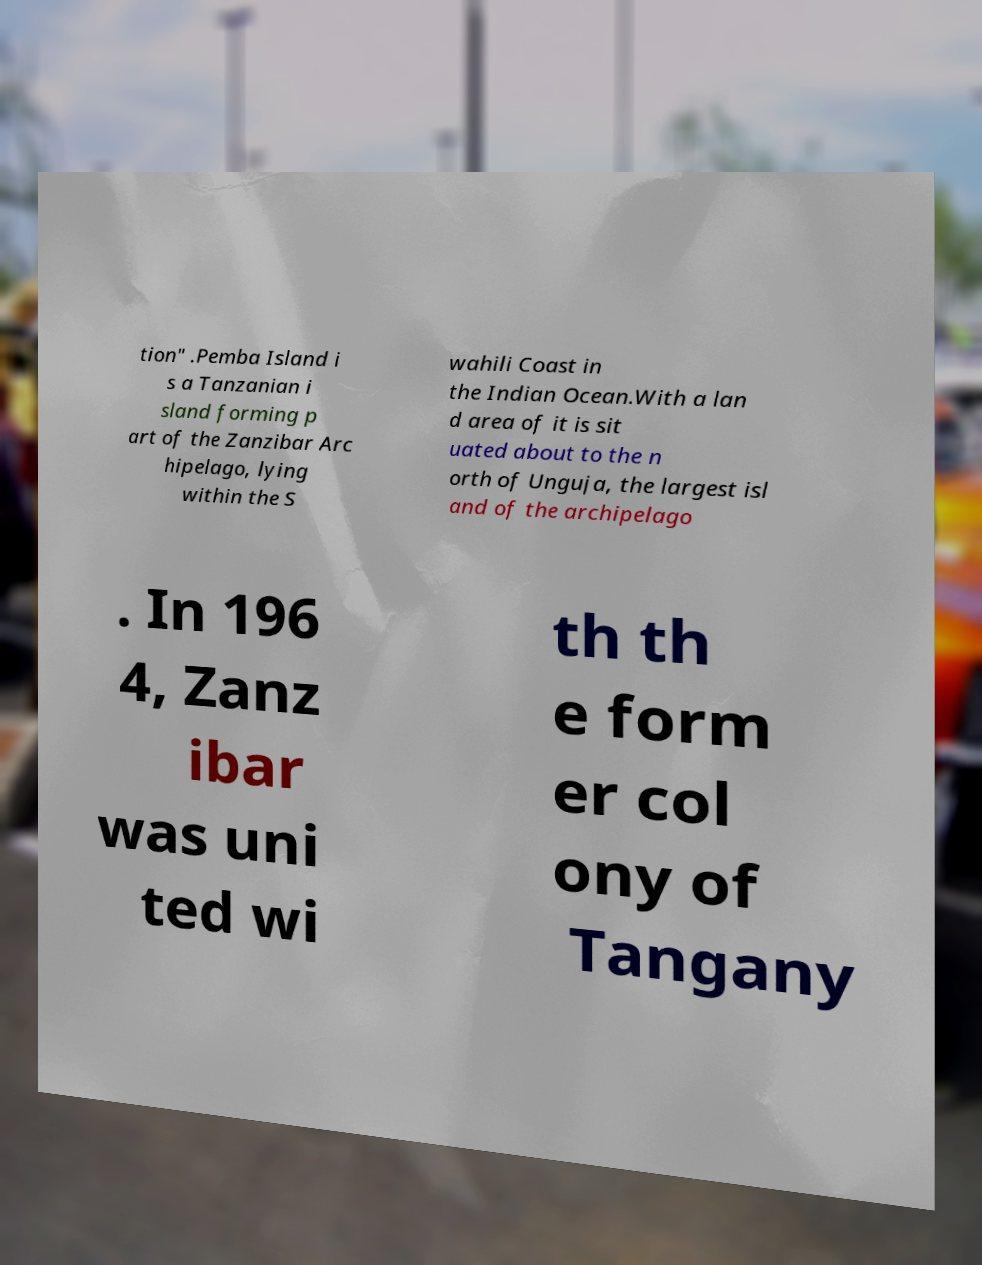Please identify and transcribe the text found in this image. tion" .Pemba Island i s a Tanzanian i sland forming p art of the Zanzibar Arc hipelago, lying within the S wahili Coast in the Indian Ocean.With a lan d area of it is sit uated about to the n orth of Unguja, the largest isl and of the archipelago . In 196 4, Zanz ibar was uni ted wi th th e form er col ony of Tangany 